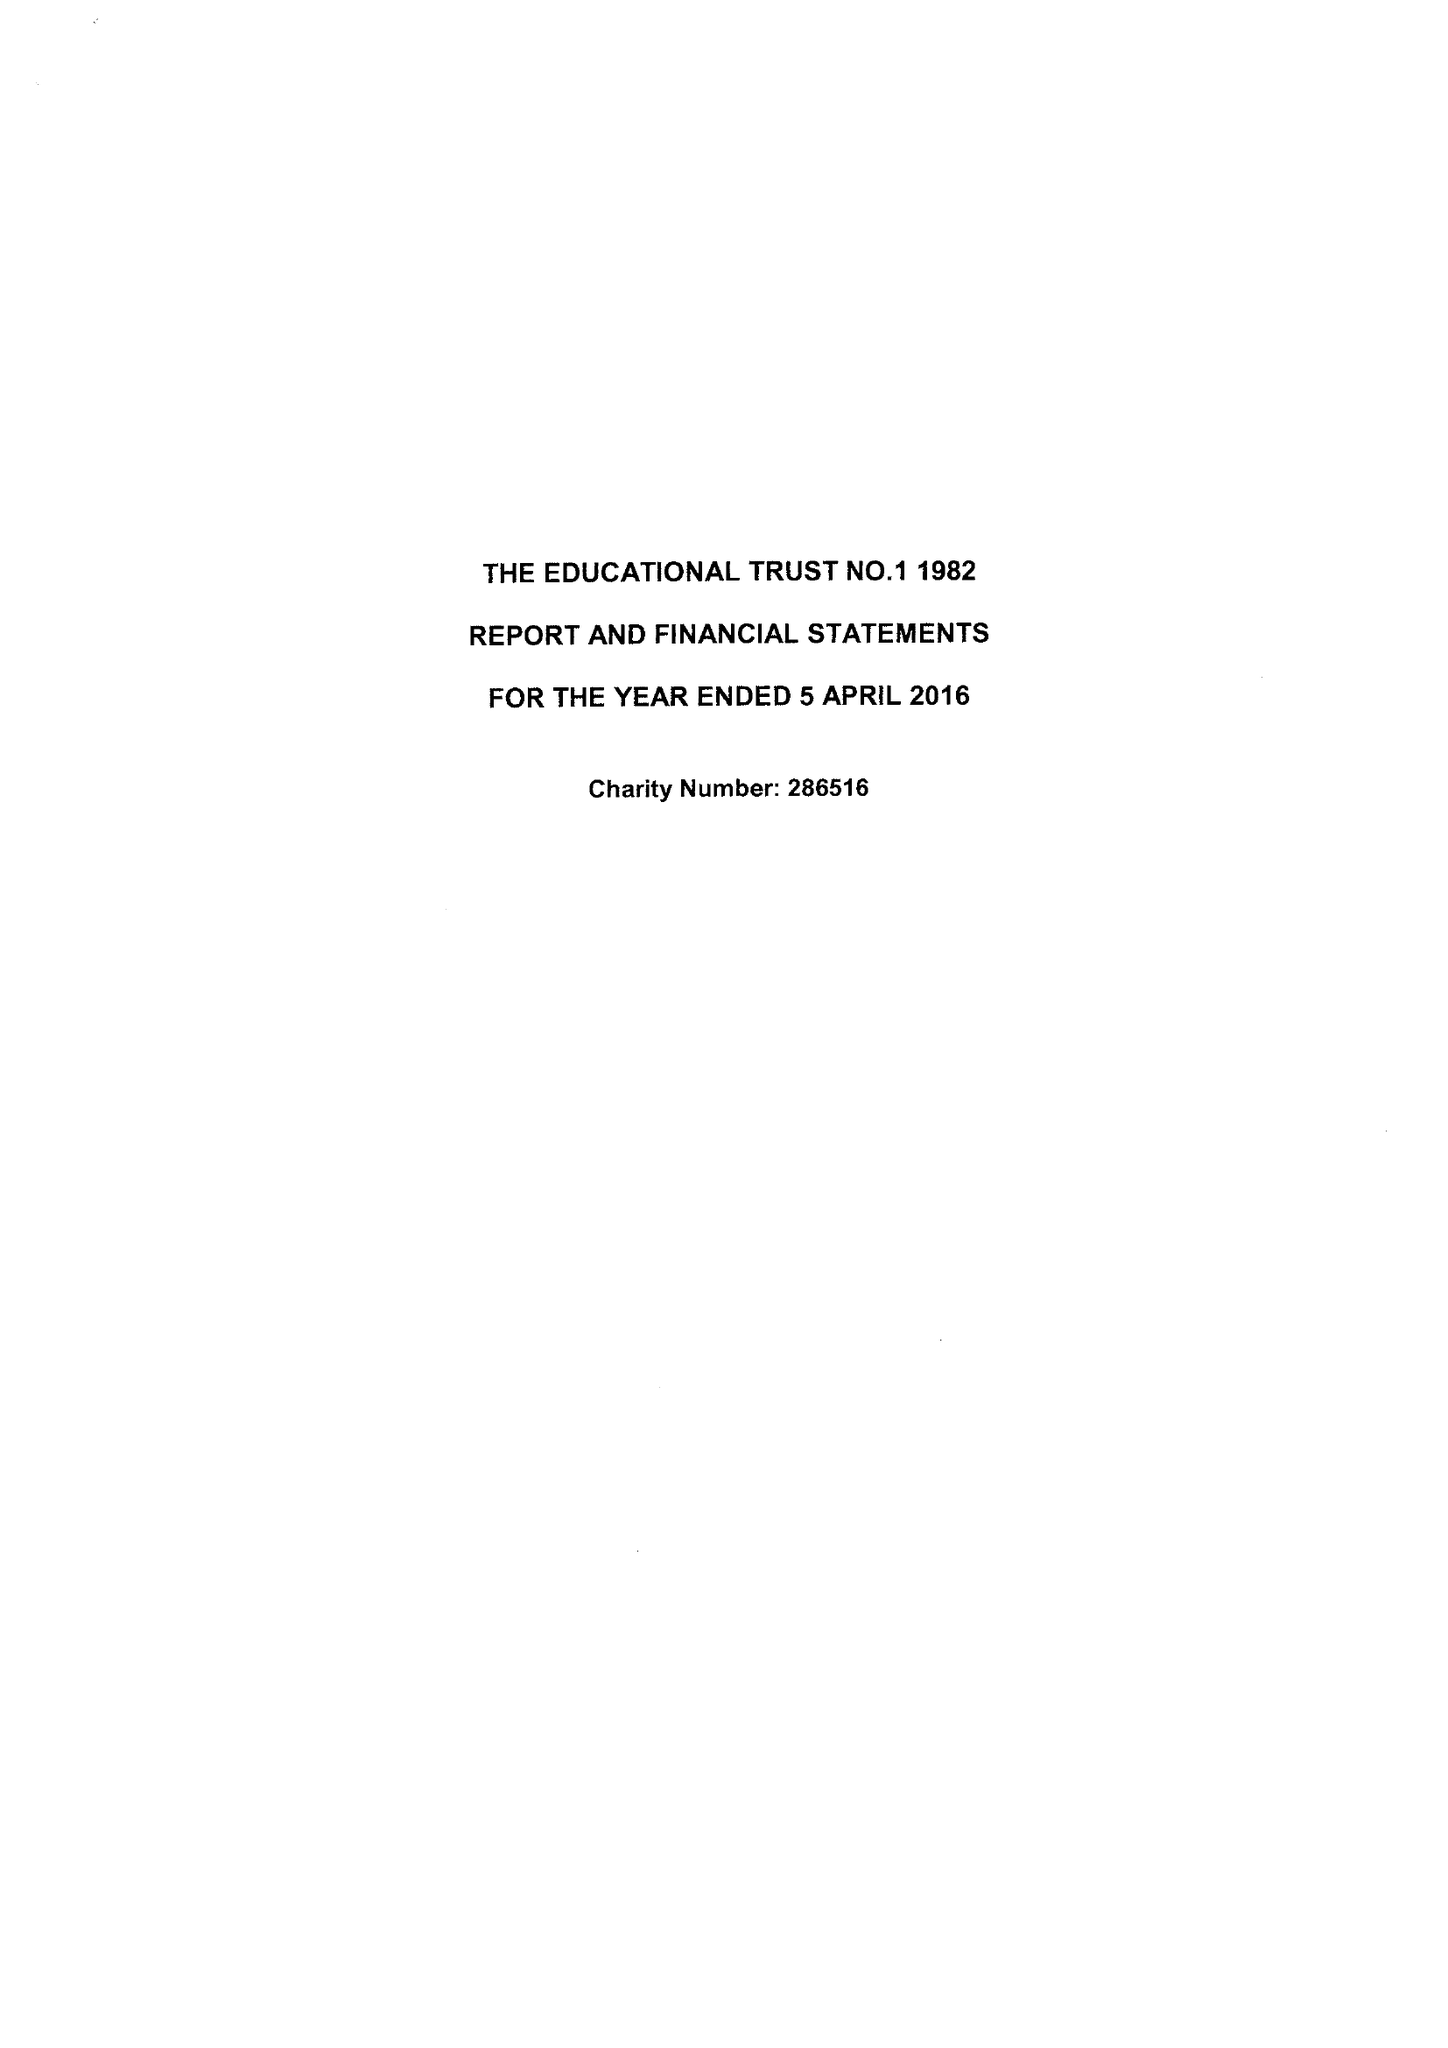What is the value for the address__post_town?
Answer the question using a single word or phrase. FAREHAM 